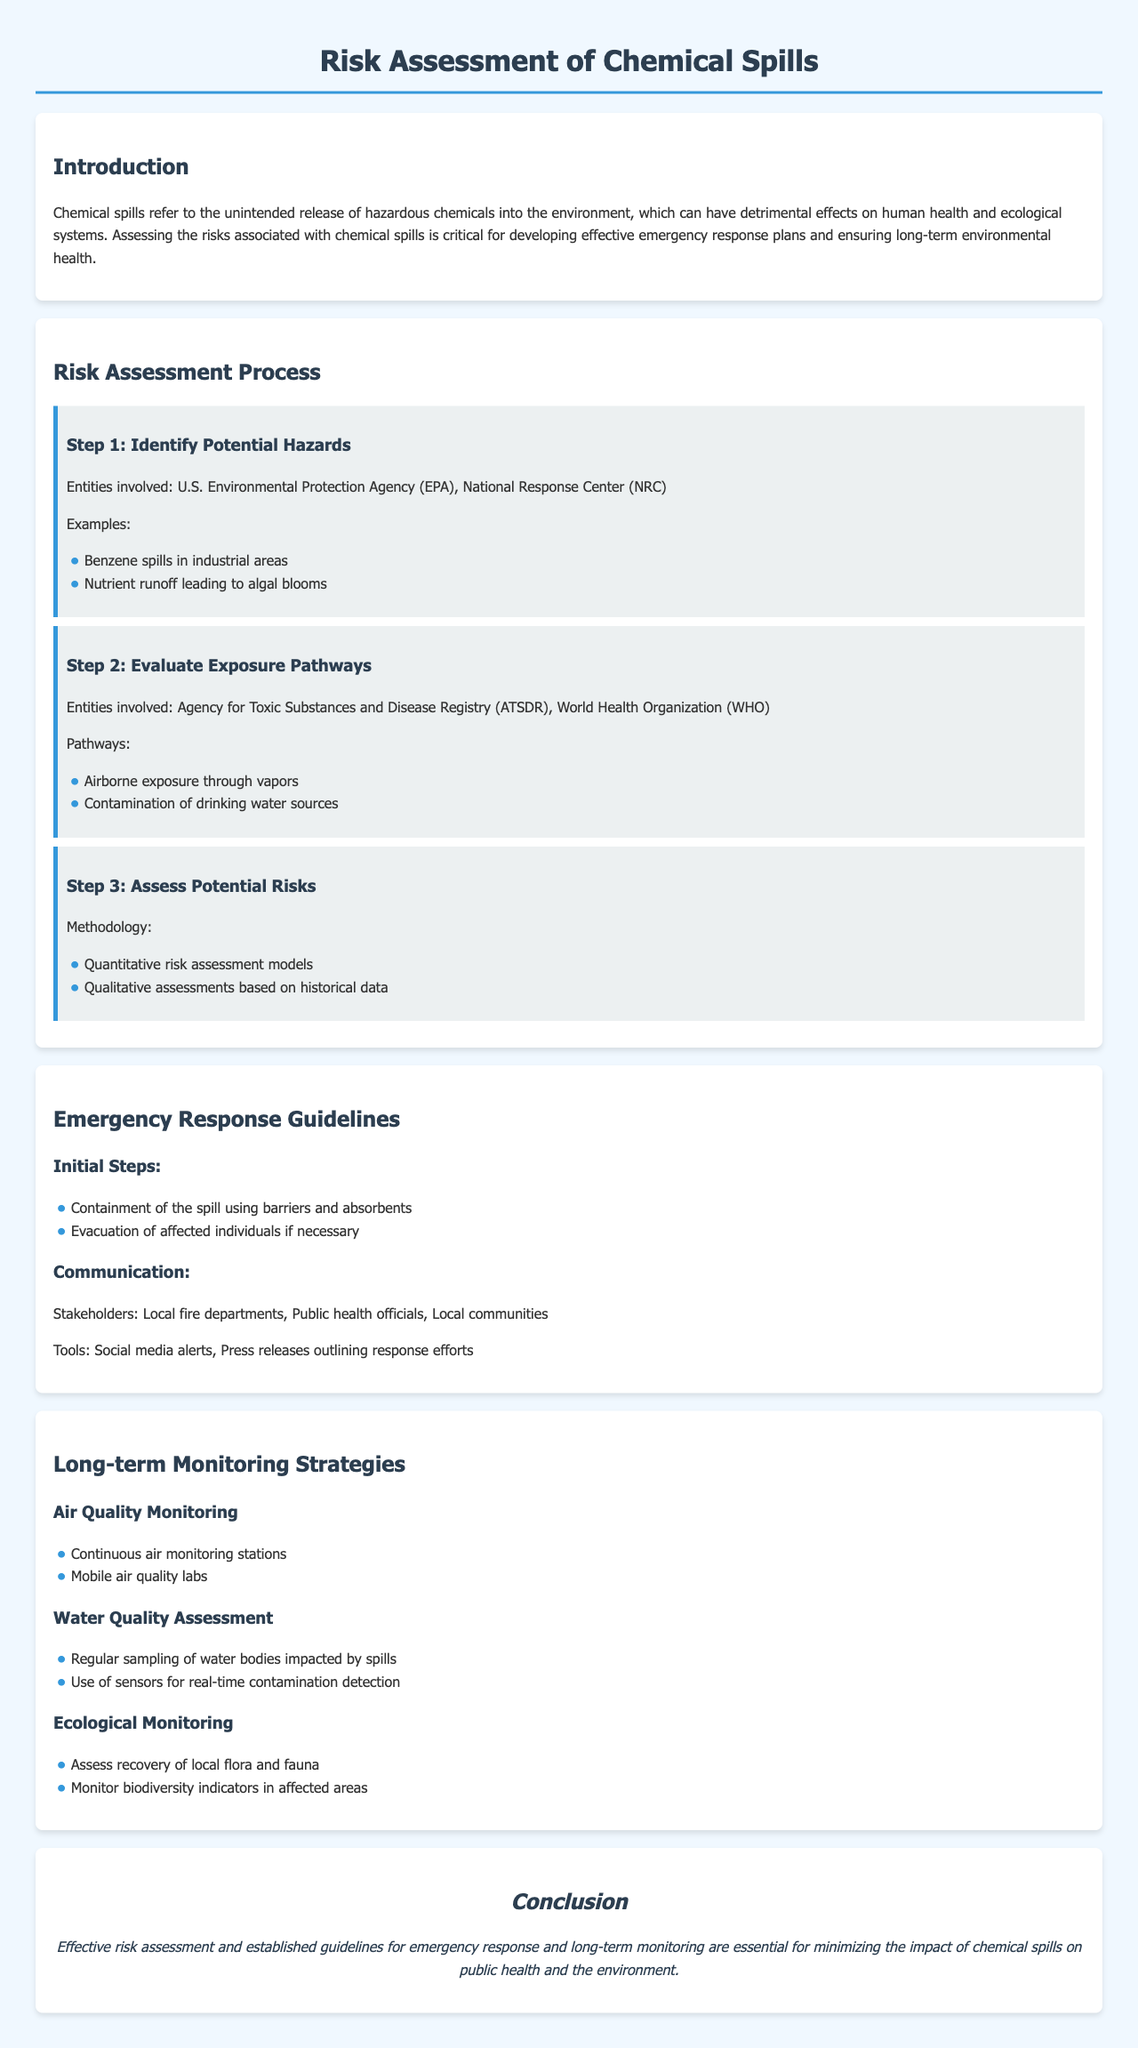What is the title of the document? The title of the document is presented in the header, which outlines the main topic of discussion.
Answer: Risk Assessment of Chemical Spills Who are the entities involved in identifying potential hazards? These entities are mentioned in the risk assessment process, highlighting their role in the initial steps.
Answer: U.S. Environmental Protection Agency (EPA), National Response Center (NRC) What is one example of a potential hazard mentioned? The report provides examples of potential hazards in the context of chemical spills to illustrate the risks involved.
Answer: Benzene spills in industrial areas What method is mentioned for assessing potential risks? The methodology section provides options for evaluating risks, highlighting the approaches used in the assessment.
Answer: Quantitative risk assessment models What is the initial step in the emergency response guidelines? The initial actions outlined specify what should be done first in the event of a chemical spill.
Answer: Containment of the spill using barriers and absorbents What type of monitoring is included under long-term monitoring strategies? The document specifies different monitoring strategies employed for ensuring environmental safety following a spill.
Answer: Air Quality Monitoring Which stakeholders are identified for communication during an emergency? The report lists key groups that should receive communication during a chemical spill scenario.
Answer: Local fire departments, Public health officials, Local communities How many steps are outlined in the risk assessment process? The document clearly presents the number of steps involved in the risk assessment process for clarity.
Answer: 3 